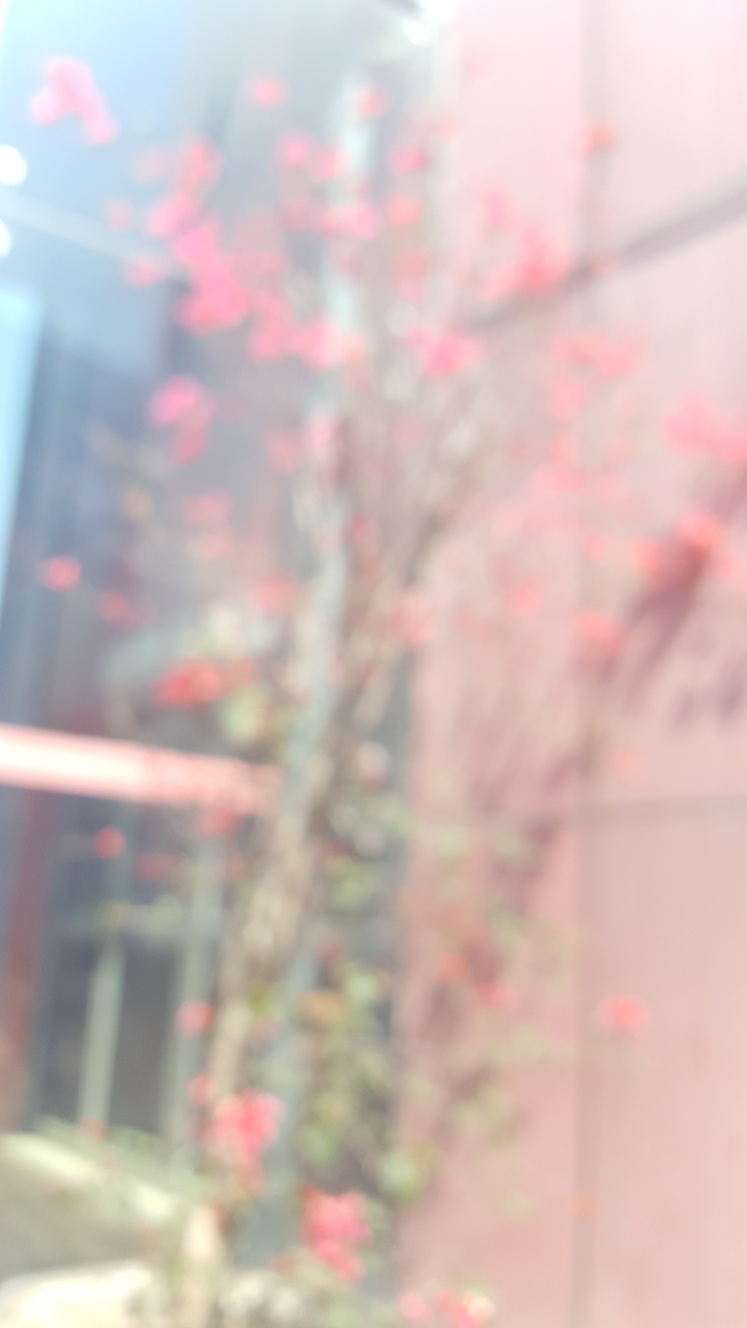Does the image capture a tree?
 Yes 